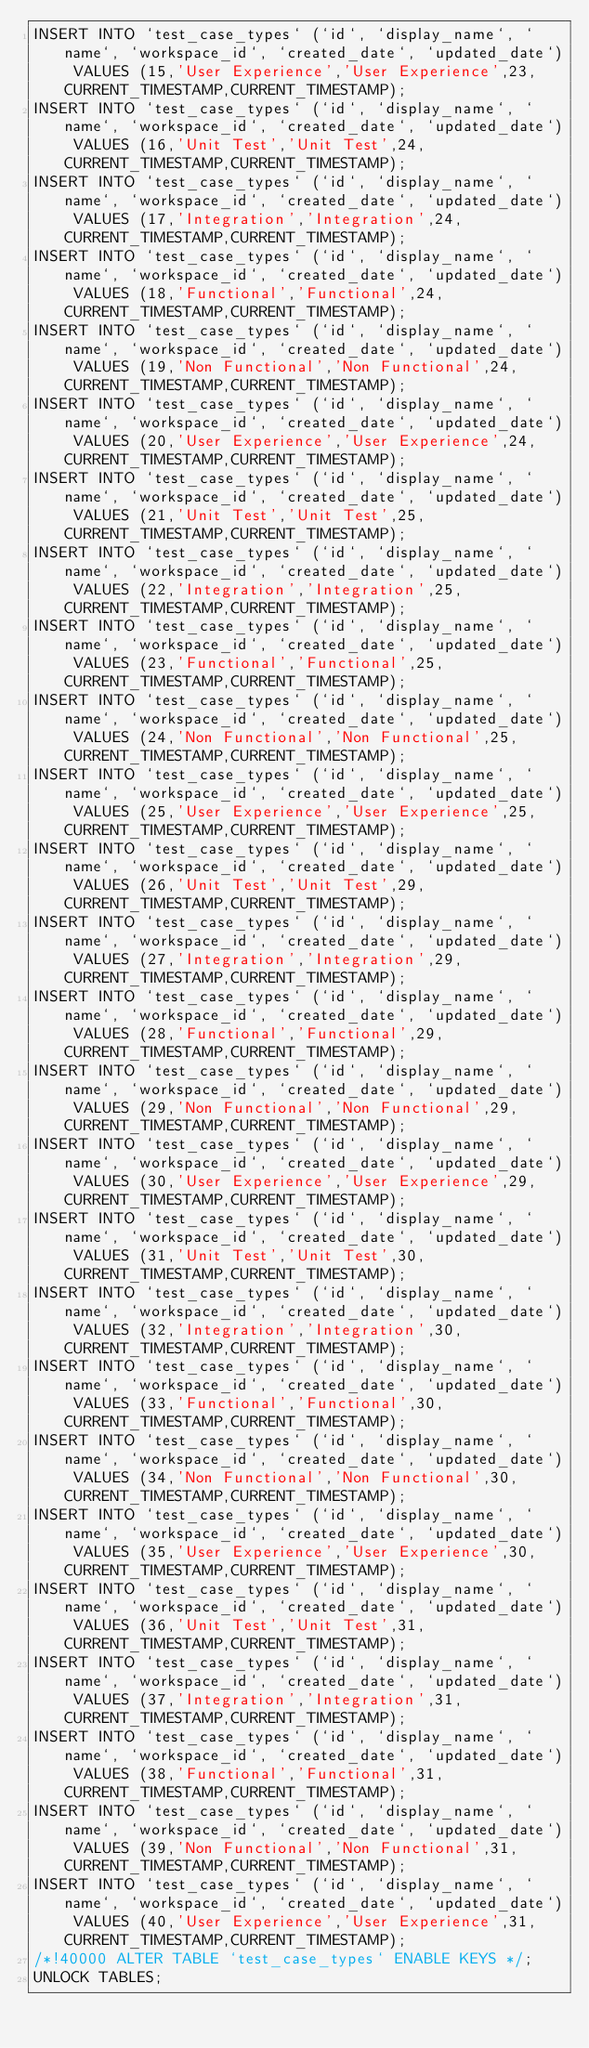<code> <loc_0><loc_0><loc_500><loc_500><_SQL_>INSERT INTO `test_case_types` (`id`, `display_name`, `name`, `workspace_id`, `created_date`, `updated_date`) VALUES (15,'User Experience','User Experience',23,CURRENT_TIMESTAMP,CURRENT_TIMESTAMP);
INSERT INTO `test_case_types` (`id`, `display_name`, `name`, `workspace_id`, `created_date`, `updated_date`) VALUES (16,'Unit Test','Unit Test',24,CURRENT_TIMESTAMP,CURRENT_TIMESTAMP);
INSERT INTO `test_case_types` (`id`, `display_name`, `name`, `workspace_id`, `created_date`, `updated_date`) VALUES (17,'Integration','Integration',24,CURRENT_TIMESTAMP,CURRENT_TIMESTAMP);
INSERT INTO `test_case_types` (`id`, `display_name`, `name`, `workspace_id`, `created_date`, `updated_date`) VALUES (18,'Functional','Functional',24,CURRENT_TIMESTAMP,CURRENT_TIMESTAMP);
INSERT INTO `test_case_types` (`id`, `display_name`, `name`, `workspace_id`, `created_date`, `updated_date`) VALUES (19,'Non Functional','Non Functional',24,CURRENT_TIMESTAMP,CURRENT_TIMESTAMP);
INSERT INTO `test_case_types` (`id`, `display_name`, `name`, `workspace_id`, `created_date`, `updated_date`) VALUES (20,'User Experience','User Experience',24,CURRENT_TIMESTAMP,CURRENT_TIMESTAMP);
INSERT INTO `test_case_types` (`id`, `display_name`, `name`, `workspace_id`, `created_date`, `updated_date`) VALUES (21,'Unit Test','Unit Test',25,CURRENT_TIMESTAMP,CURRENT_TIMESTAMP);
INSERT INTO `test_case_types` (`id`, `display_name`, `name`, `workspace_id`, `created_date`, `updated_date`) VALUES (22,'Integration','Integration',25,CURRENT_TIMESTAMP,CURRENT_TIMESTAMP);
INSERT INTO `test_case_types` (`id`, `display_name`, `name`, `workspace_id`, `created_date`, `updated_date`) VALUES (23,'Functional','Functional',25,CURRENT_TIMESTAMP,CURRENT_TIMESTAMP);
INSERT INTO `test_case_types` (`id`, `display_name`, `name`, `workspace_id`, `created_date`, `updated_date`) VALUES (24,'Non Functional','Non Functional',25,CURRENT_TIMESTAMP,CURRENT_TIMESTAMP);
INSERT INTO `test_case_types` (`id`, `display_name`, `name`, `workspace_id`, `created_date`, `updated_date`) VALUES (25,'User Experience','User Experience',25,CURRENT_TIMESTAMP,CURRENT_TIMESTAMP);
INSERT INTO `test_case_types` (`id`, `display_name`, `name`, `workspace_id`, `created_date`, `updated_date`) VALUES (26,'Unit Test','Unit Test',29,CURRENT_TIMESTAMP,CURRENT_TIMESTAMP);
INSERT INTO `test_case_types` (`id`, `display_name`, `name`, `workspace_id`, `created_date`, `updated_date`) VALUES (27,'Integration','Integration',29,CURRENT_TIMESTAMP,CURRENT_TIMESTAMP);
INSERT INTO `test_case_types` (`id`, `display_name`, `name`, `workspace_id`, `created_date`, `updated_date`) VALUES (28,'Functional','Functional',29,CURRENT_TIMESTAMP,CURRENT_TIMESTAMP);
INSERT INTO `test_case_types` (`id`, `display_name`, `name`, `workspace_id`, `created_date`, `updated_date`) VALUES (29,'Non Functional','Non Functional',29,CURRENT_TIMESTAMP,CURRENT_TIMESTAMP);
INSERT INTO `test_case_types` (`id`, `display_name`, `name`, `workspace_id`, `created_date`, `updated_date`) VALUES (30,'User Experience','User Experience',29,CURRENT_TIMESTAMP,CURRENT_TIMESTAMP);
INSERT INTO `test_case_types` (`id`, `display_name`, `name`, `workspace_id`, `created_date`, `updated_date`) VALUES (31,'Unit Test','Unit Test',30,CURRENT_TIMESTAMP,CURRENT_TIMESTAMP);
INSERT INTO `test_case_types` (`id`, `display_name`, `name`, `workspace_id`, `created_date`, `updated_date`) VALUES (32,'Integration','Integration',30,CURRENT_TIMESTAMP,CURRENT_TIMESTAMP);
INSERT INTO `test_case_types` (`id`, `display_name`, `name`, `workspace_id`, `created_date`, `updated_date`) VALUES (33,'Functional','Functional',30,CURRENT_TIMESTAMP,CURRENT_TIMESTAMP);
INSERT INTO `test_case_types` (`id`, `display_name`, `name`, `workspace_id`, `created_date`, `updated_date`) VALUES (34,'Non Functional','Non Functional',30,CURRENT_TIMESTAMP,CURRENT_TIMESTAMP);
INSERT INTO `test_case_types` (`id`, `display_name`, `name`, `workspace_id`, `created_date`, `updated_date`) VALUES (35,'User Experience','User Experience',30,CURRENT_TIMESTAMP,CURRENT_TIMESTAMP);
INSERT INTO `test_case_types` (`id`, `display_name`, `name`, `workspace_id`, `created_date`, `updated_date`) VALUES (36,'Unit Test','Unit Test',31,CURRENT_TIMESTAMP,CURRENT_TIMESTAMP);
INSERT INTO `test_case_types` (`id`, `display_name`, `name`, `workspace_id`, `created_date`, `updated_date`) VALUES (37,'Integration','Integration',31,CURRENT_TIMESTAMP,CURRENT_TIMESTAMP);
INSERT INTO `test_case_types` (`id`, `display_name`, `name`, `workspace_id`, `created_date`, `updated_date`) VALUES (38,'Functional','Functional',31,CURRENT_TIMESTAMP,CURRENT_TIMESTAMP);
INSERT INTO `test_case_types` (`id`, `display_name`, `name`, `workspace_id`, `created_date`, `updated_date`) VALUES (39,'Non Functional','Non Functional',31,CURRENT_TIMESTAMP,CURRENT_TIMESTAMP);
INSERT INTO `test_case_types` (`id`, `display_name`, `name`, `workspace_id`, `created_date`, `updated_date`) VALUES (40,'User Experience','User Experience',31,CURRENT_TIMESTAMP,CURRENT_TIMESTAMP);
/*!40000 ALTER TABLE `test_case_types` ENABLE KEYS */;
UNLOCK TABLES;
</code> 